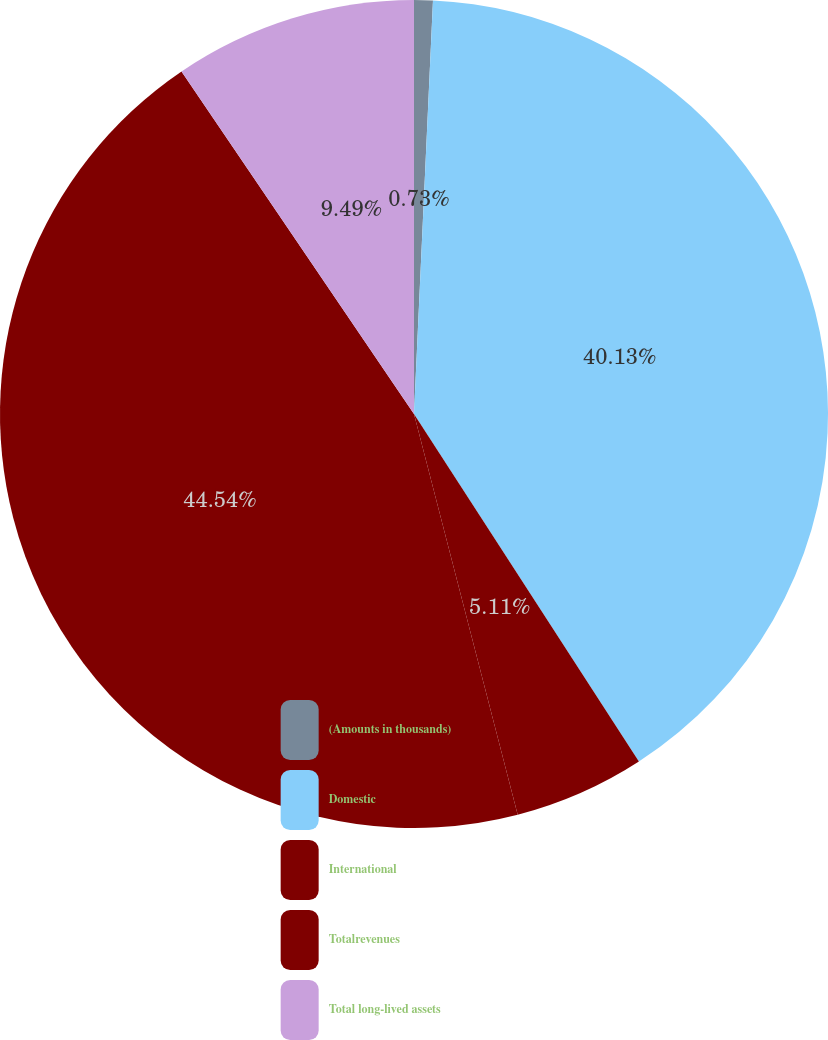Convert chart. <chart><loc_0><loc_0><loc_500><loc_500><pie_chart><fcel>(Amounts in thousands)<fcel>Domestic<fcel>International<fcel>Totalrevenues<fcel>Total long-lived assets<nl><fcel>0.73%<fcel>40.13%<fcel>5.11%<fcel>44.54%<fcel>9.49%<nl></chart> 